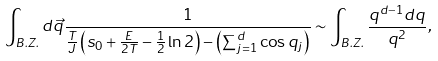Convert formula to latex. <formula><loc_0><loc_0><loc_500><loc_500>\int _ { B . Z . } d \vec { q } \frac { 1 } { \frac { T } { J } \left ( s _ { 0 } + \frac { E } { 2 T } - \frac { 1 } { 2 } \ln 2 \right ) - \left ( \sum _ { j = 1 } ^ { d } \cos q _ { j } \right ) } \sim \int _ { B . Z . } \frac { q ^ { d - 1 } d q } { q ^ { 2 } } ,</formula> 